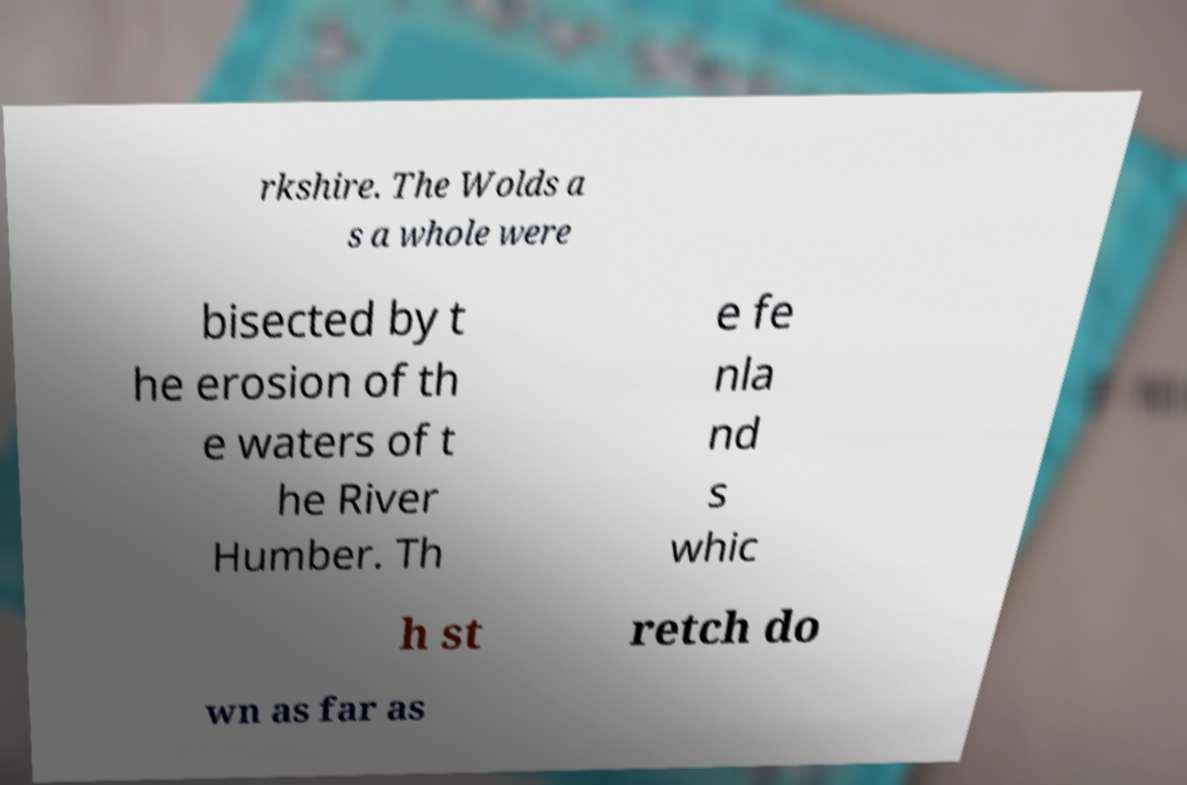What messages or text are displayed in this image? I need them in a readable, typed format. rkshire. The Wolds a s a whole were bisected by t he erosion of th e waters of t he River Humber. Th e fe nla nd s whic h st retch do wn as far as 